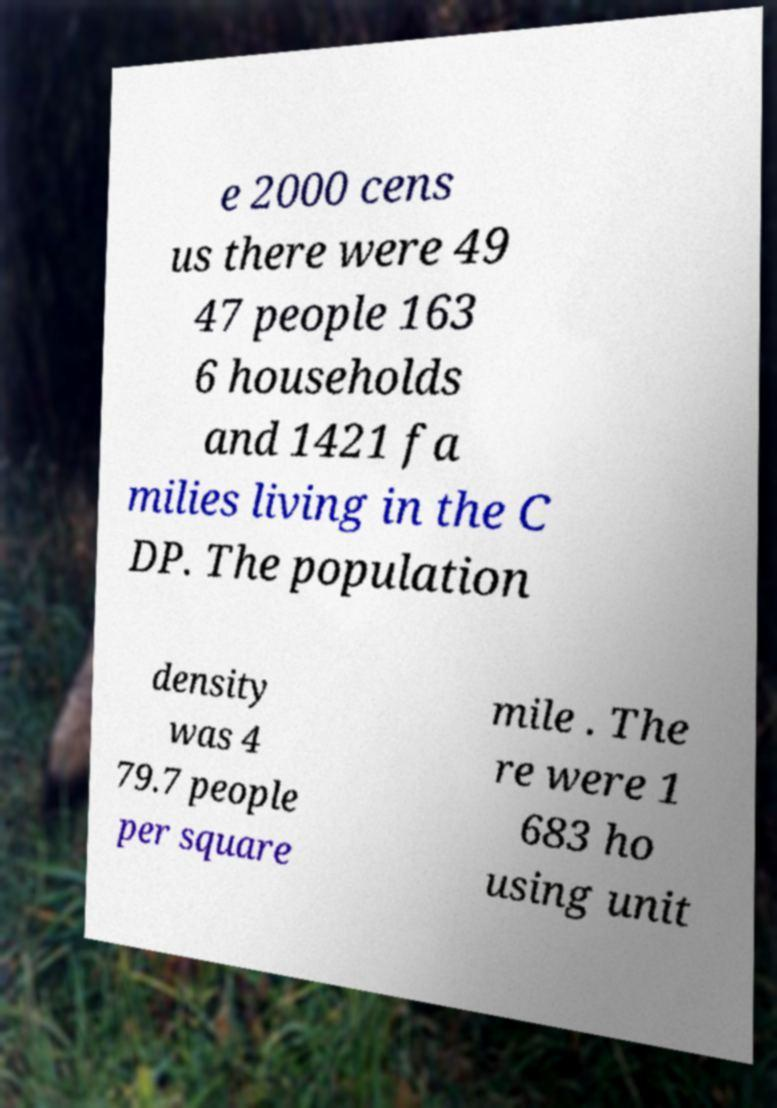What messages or text are displayed in this image? I need them in a readable, typed format. e 2000 cens us there were 49 47 people 163 6 households and 1421 fa milies living in the C DP. The population density was 4 79.7 people per square mile . The re were 1 683 ho using unit 